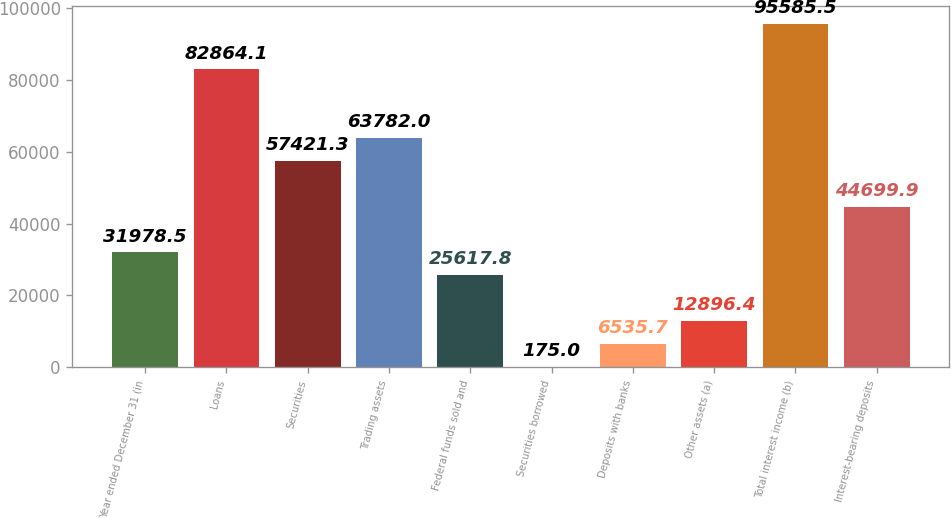Convert chart. <chart><loc_0><loc_0><loc_500><loc_500><bar_chart><fcel>Year ended December 31 (in<fcel>Loans<fcel>Securities<fcel>Trading assets<fcel>Federal funds sold and<fcel>Securities borrowed<fcel>Deposits with banks<fcel>Other assets (a)<fcel>Total interest income (b)<fcel>Interest-bearing deposits<nl><fcel>31978.5<fcel>82864.1<fcel>57421.3<fcel>63782<fcel>25617.8<fcel>175<fcel>6535.7<fcel>12896.4<fcel>95585.5<fcel>44699.9<nl></chart> 